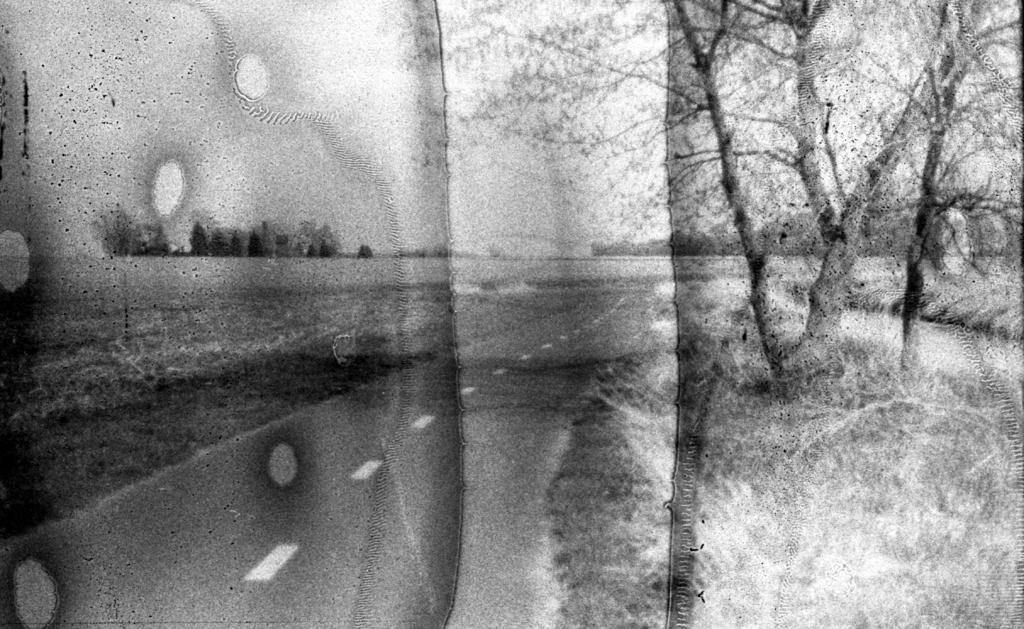What type of image is being shown? The image is an edited picture. What can be seen in the image besides the edited elements? There are trees, the sky, a road, and grass visible in the image. Where is the road located in the image? The road is at the bottom of the image. What is visible at the top of the image? The sky is visible at the top of the image. How many rings are visible on the side of the trees in the image? There are no rings visible on the trees in the image, nor is there any mention of rings or sides in the provided facts. 